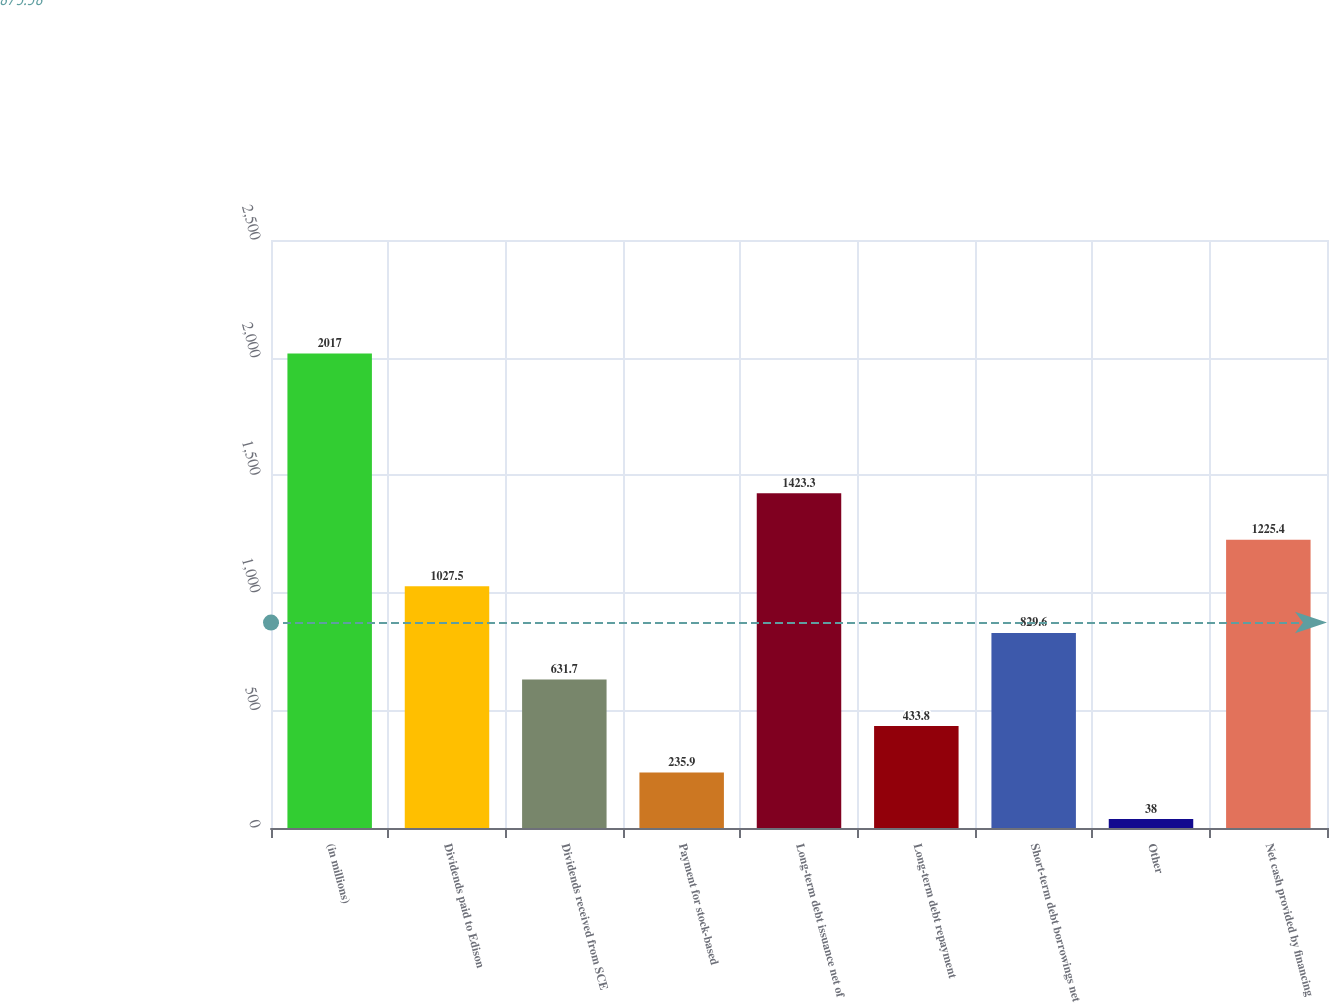Convert chart to OTSL. <chart><loc_0><loc_0><loc_500><loc_500><bar_chart><fcel>(in millions)<fcel>Dividends paid to Edison<fcel>Dividends received from SCE<fcel>Payment for stock-based<fcel>Long-term debt issuance net of<fcel>Long-term debt repayment<fcel>Short-term debt borrowings net<fcel>Other<fcel>Net cash provided by financing<nl><fcel>2017<fcel>1027.5<fcel>631.7<fcel>235.9<fcel>1423.3<fcel>433.8<fcel>829.6<fcel>38<fcel>1225.4<nl></chart> 